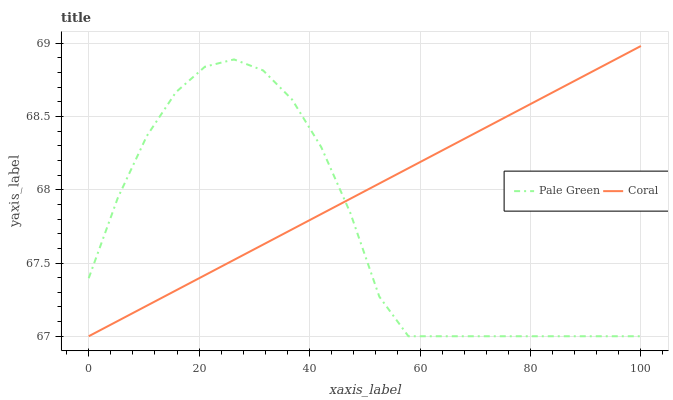Does Pale Green have the minimum area under the curve?
Answer yes or no. Yes. Does Coral have the maximum area under the curve?
Answer yes or no. Yes. Does Pale Green have the maximum area under the curve?
Answer yes or no. No. Is Coral the smoothest?
Answer yes or no. Yes. Is Pale Green the roughest?
Answer yes or no. Yes. Is Pale Green the smoothest?
Answer yes or no. No. Does Coral have the lowest value?
Answer yes or no. Yes. Does Coral have the highest value?
Answer yes or no. Yes. Does Pale Green have the highest value?
Answer yes or no. No. Does Coral intersect Pale Green?
Answer yes or no. Yes. Is Coral less than Pale Green?
Answer yes or no. No. Is Coral greater than Pale Green?
Answer yes or no. No. 